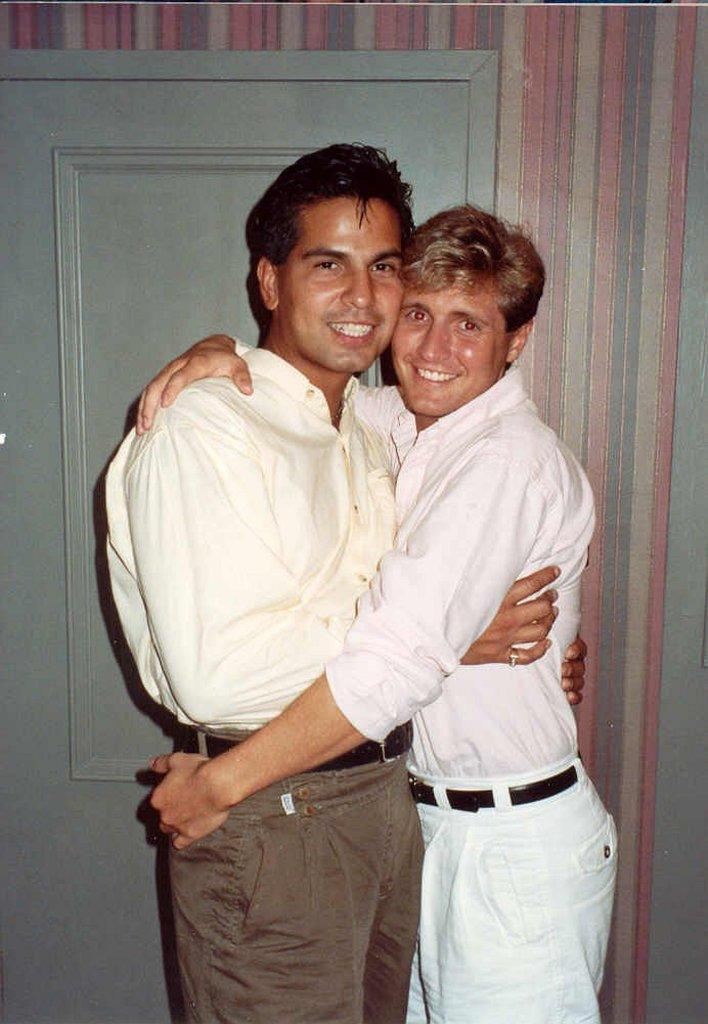How many people are in the image? There are two persons in the center of the picture. What is the facial expression of the persons in the image? The persons have smiling faces. What can be seen in the background of the image? There is a wall and a door in the background of the image. What type of cake is being cut by the persons in the image? There is no cake present in the image; it features two persons with smiling faces in the center and a wall and a door in the background. 